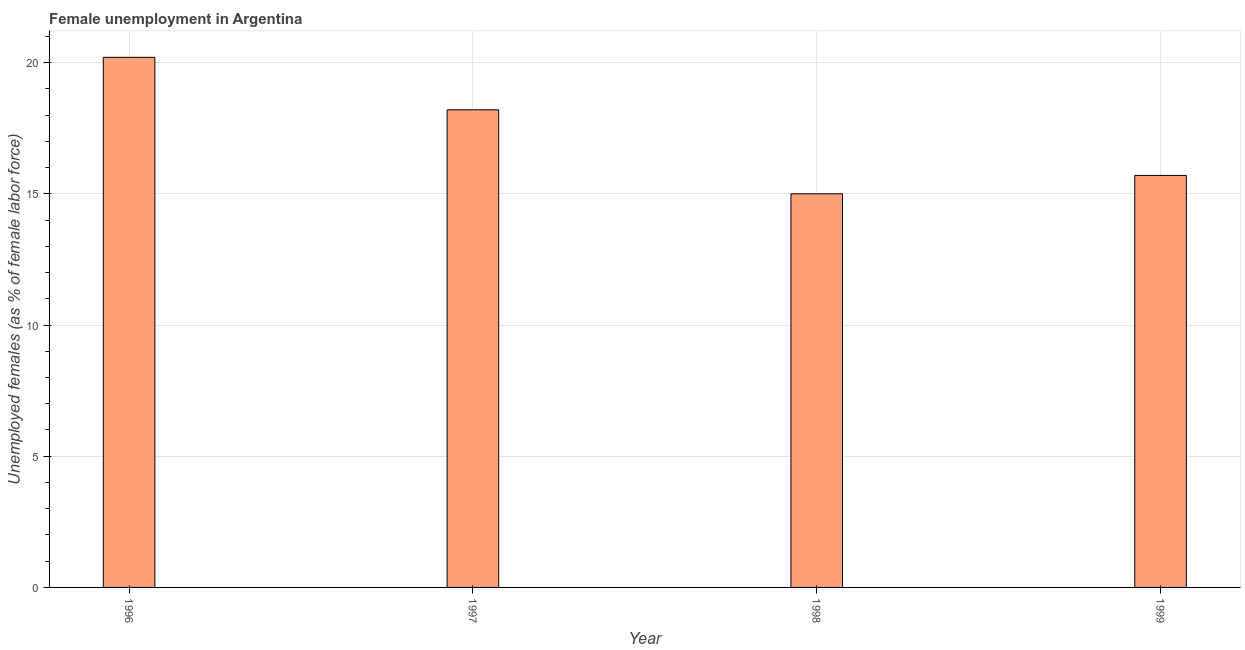What is the title of the graph?
Ensure brevity in your answer.  Female unemployment in Argentina. What is the label or title of the X-axis?
Provide a short and direct response. Year. What is the label or title of the Y-axis?
Offer a terse response. Unemployed females (as % of female labor force). What is the unemployed females population in 1998?
Provide a succinct answer. 15. Across all years, what is the maximum unemployed females population?
Ensure brevity in your answer.  20.2. What is the sum of the unemployed females population?
Your answer should be very brief. 69.1. What is the difference between the unemployed females population in 1996 and 1999?
Keep it short and to the point. 4.5. What is the average unemployed females population per year?
Your answer should be very brief. 17.27. What is the median unemployed females population?
Offer a very short reply. 16.95. In how many years, is the unemployed females population greater than 8 %?
Give a very brief answer. 4. What is the ratio of the unemployed females population in 1996 to that in 1999?
Provide a short and direct response. 1.29. Is the difference between the unemployed females population in 1996 and 1998 greater than the difference between any two years?
Provide a succinct answer. Yes. Is the sum of the unemployed females population in 1996 and 1999 greater than the maximum unemployed females population across all years?
Offer a terse response. Yes. What is the difference between the highest and the lowest unemployed females population?
Make the answer very short. 5.2. How many bars are there?
Provide a succinct answer. 4. Are all the bars in the graph horizontal?
Provide a succinct answer. No. What is the Unemployed females (as % of female labor force) of 1996?
Offer a terse response. 20.2. What is the Unemployed females (as % of female labor force) in 1997?
Offer a terse response. 18.2. What is the Unemployed females (as % of female labor force) in 1999?
Your response must be concise. 15.7. What is the difference between the Unemployed females (as % of female labor force) in 1996 and 1997?
Offer a terse response. 2. What is the difference between the Unemployed females (as % of female labor force) in 1996 and 1999?
Make the answer very short. 4.5. What is the difference between the Unemployed females (as % of female labor force) in 1997 and 1999?
Your answer should be compact. 2.5. What is the difference between the Unemployed females (as % of female labor force) in 1998 and 1999?
Offer a terse response. -0.7. What is the ratio of the Unemployed females (as % of female labor force) in 1996 to that in 1997?
Offer a very short reply. 1.11. What is the ratio of the Unemployed females (as % of female labor force) in 1996 to that in 1998?
Keep it short and to the point. 1.35. What is the ratio of the Unemployed females (as % of female labor force) in 1996 to that in 1999?
Keep it short and to the point. 1.29. What is the ratio of the Unemployed females (as % of female labor force) in 1997 to that in 1998?
Your response must be concise. 1.21. What is the ratio of the Unemployed females (as % of female labor force) in 1997 to that in 1999?
Offer a terse response. 1.16. What is the ratio of the Unemployed females (as % of female labor force) in 1998 to that in 1999?
Provide a short and direct response. 0.95. 